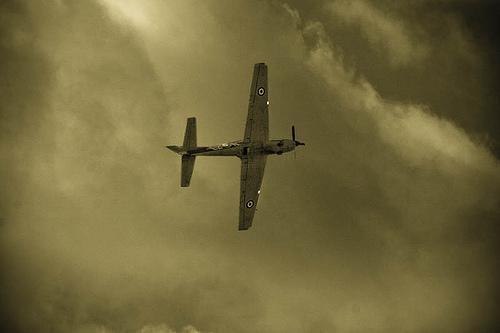How many airplanes are in the sky?
Give a very brief answer. 1. 